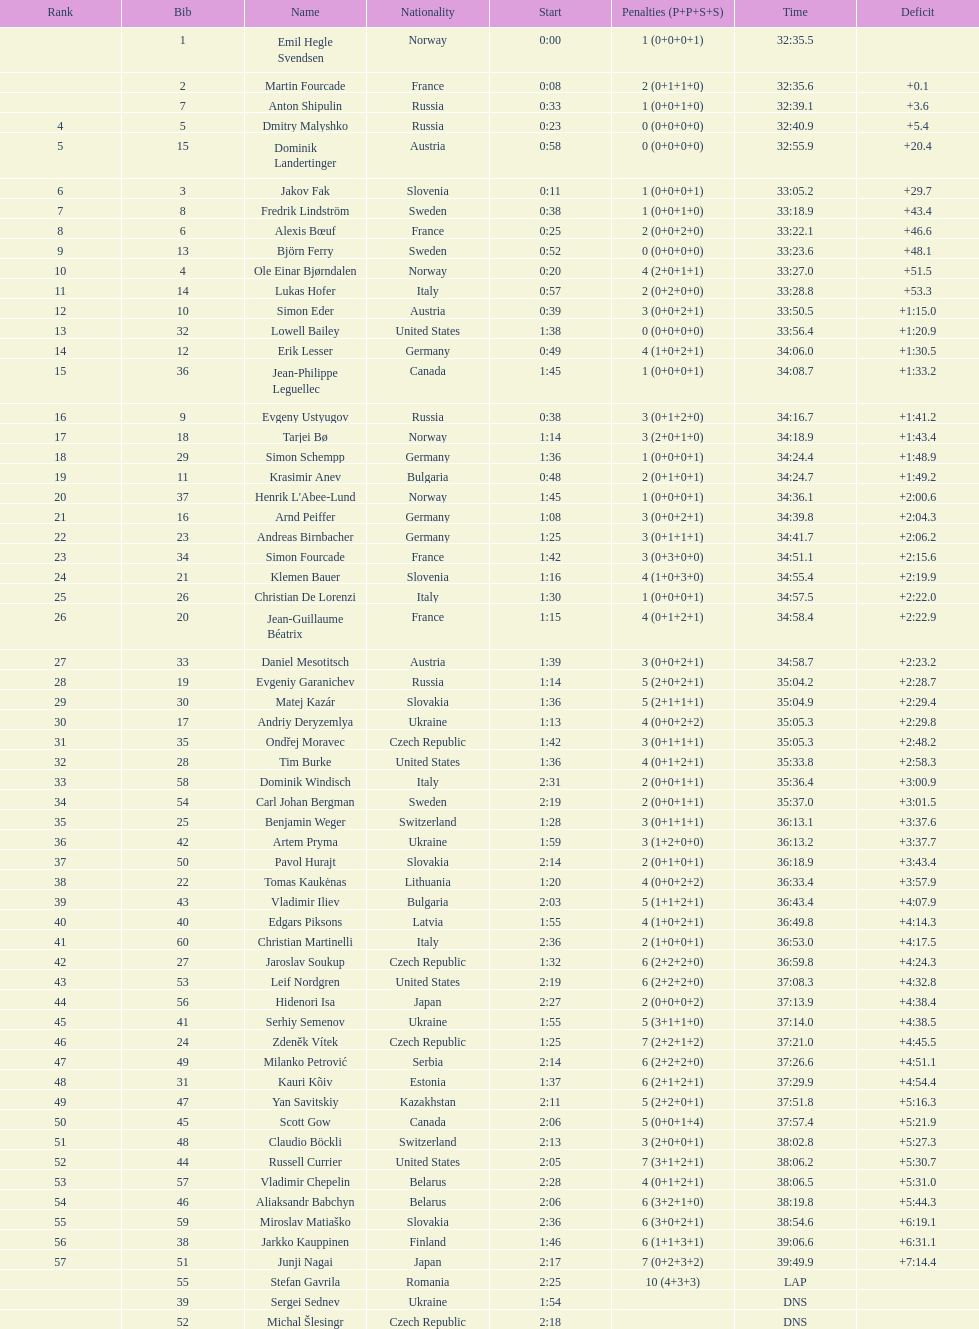Between bjorn ferry, simon elder, and erik lesser, who was penalized the most? Erik Lesser. 